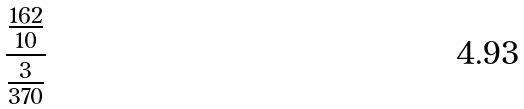<formula> <loc_0><loc_0><loc_500><loc_500>\frac { \frac { 1 6 2 } { 1 0 } } { \frac { 3 } { 3 7 0 } }</formula> 